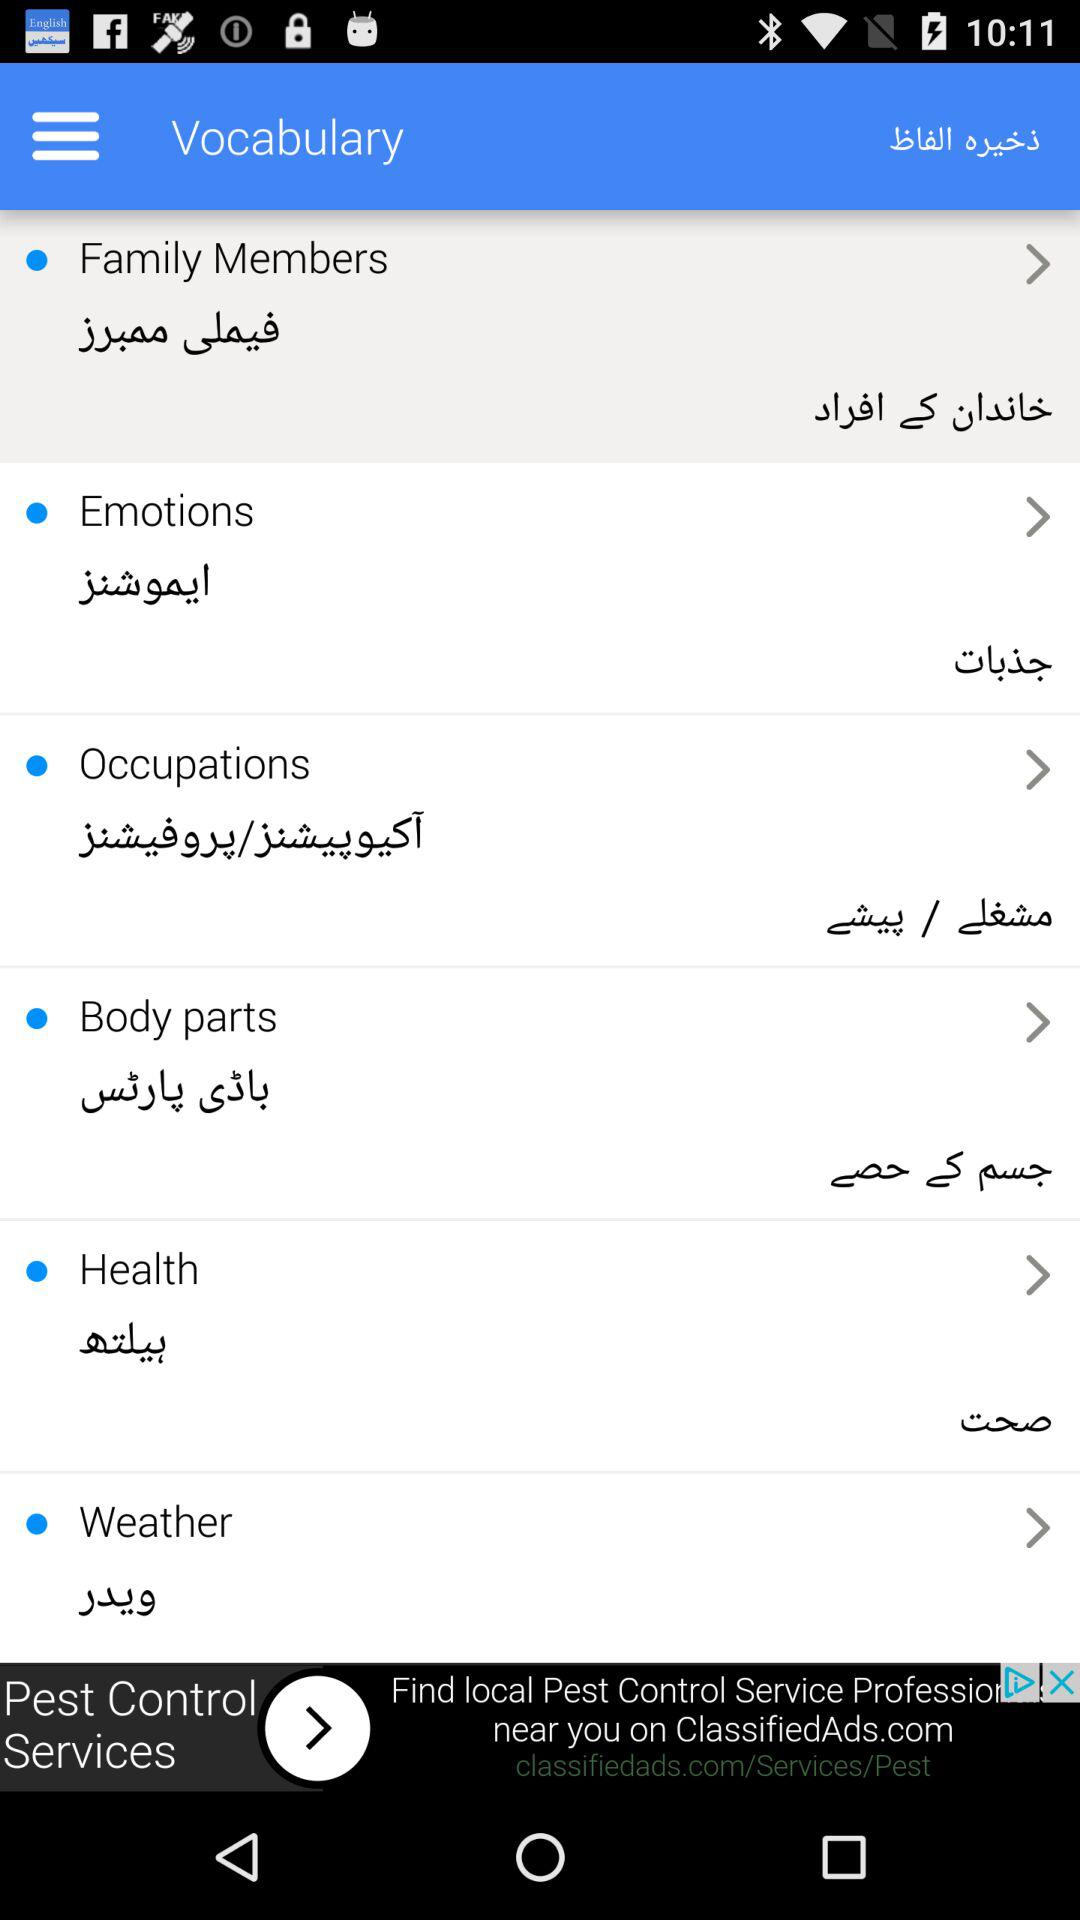What's the selected option in "Vocabulary"? The selected option in "Vocabulary" is "Family Member". 